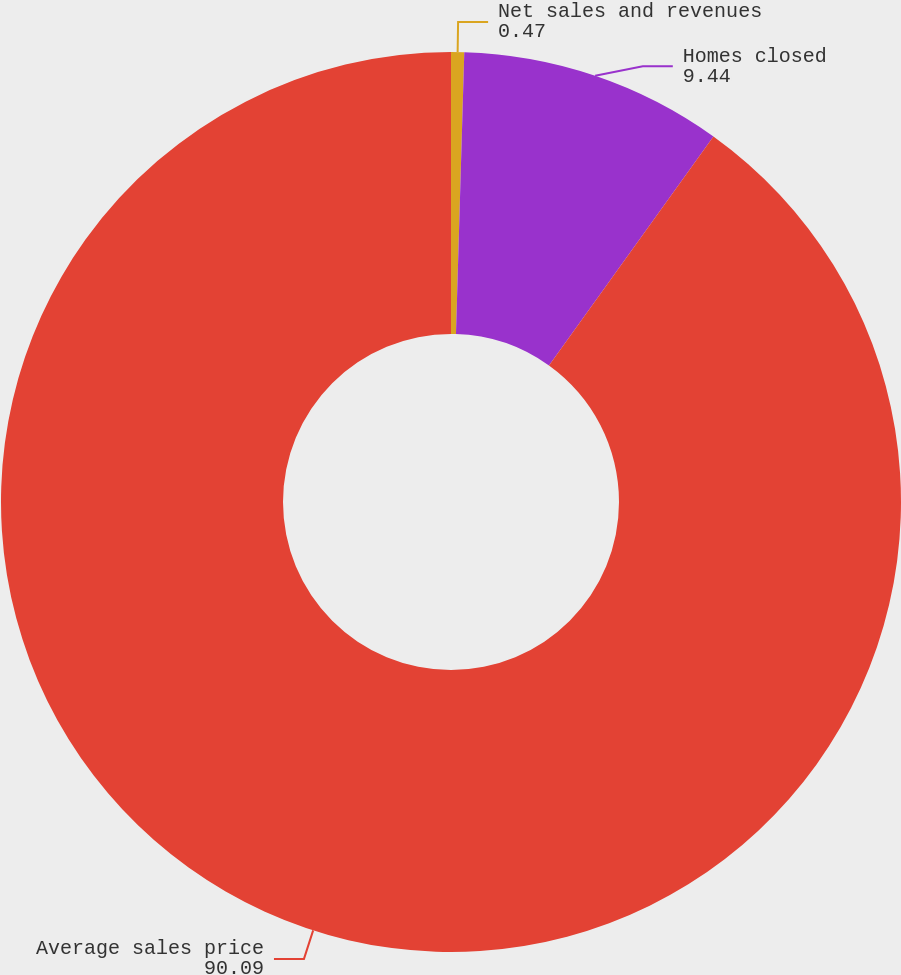<chart> <loc_0><loc_0><loc_500><loc_500><pie_chart><fcel>Net sales and revenues<fcel>Homes closed<fcel>Average sales price<nl><fcel>0.47%<fcel>9.44%<fcel>90.09%<nl></chart> 